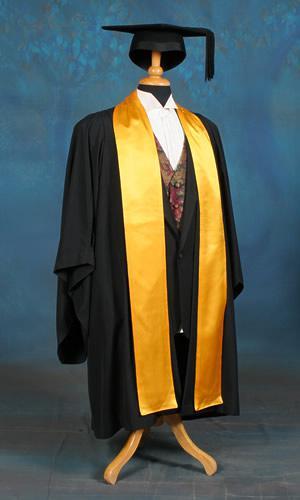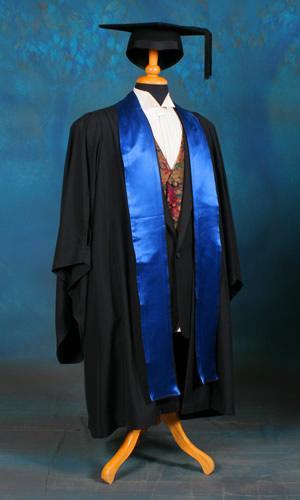The first image is the image on the left, the second image is the image on the right. Considering the images on both sides, is "At least one gown has a long gold embellishment." valid? Answer yes or no. Yes. 